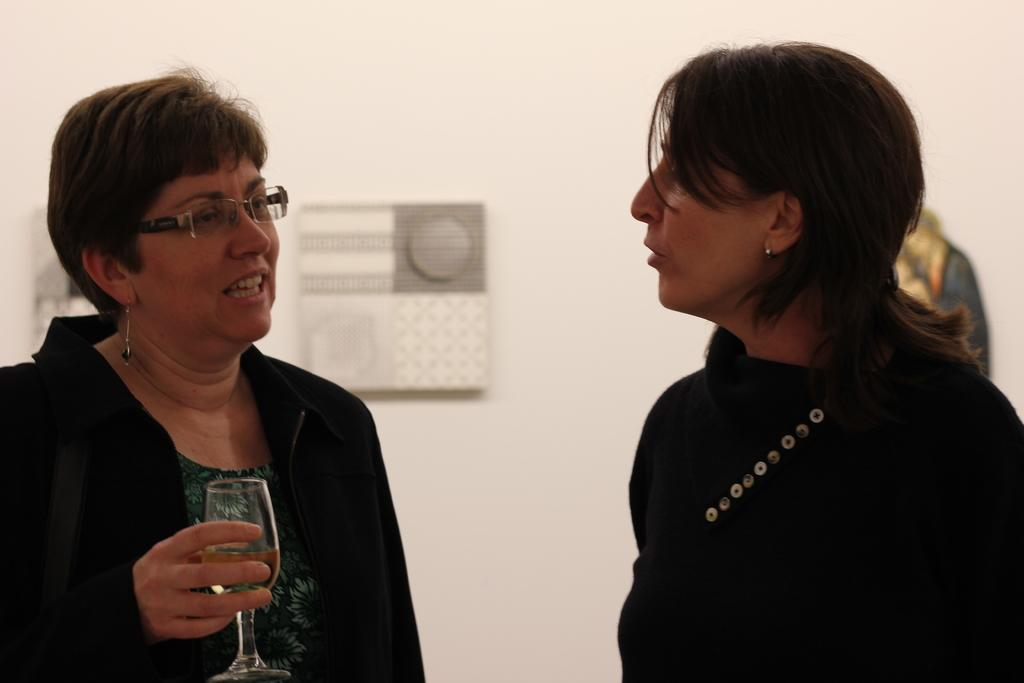How many people are in the image? There are two women in the image. What is one of the women holding? One of the women is holding a glass. What are the women doing in the image? The women are talking to each other. What can be seen in the background of the image? There is a wall in the background of the image, and there are frames on the wall. What type of print can be seen on the manager's shirt in the image? There is no manager present in the image, and therefore no shirt or print to observe. Are there any giants visible in the image? There are no giants present in the image. 